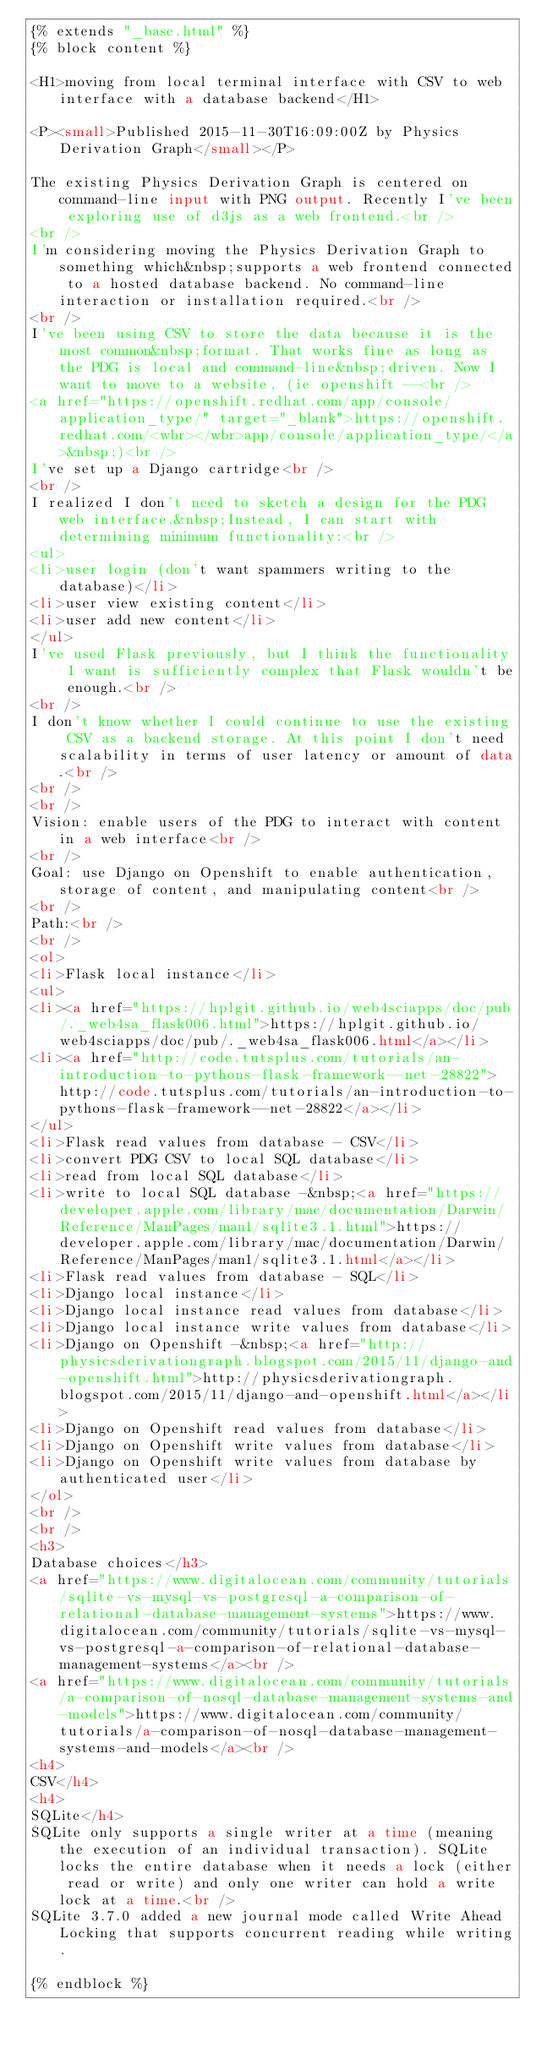<code> <loc_0><loc_0><loc_500><loc_500><_HTML_>{% extends "_base.html" %}
{% block content %}

<H1>moving from local terminal interface with CSV to web interface with a database backend</H1>

<P><small>Published 2015-11-30T16:09:00Z by Physics Derivation Graph</small></P>

The existing Physics Derivation Graph is centered on command-line input with PNG output. Recently I've been exploring use of d3js as a web frontend.<br />
<br />
I'm considering moving the Physics Derivation Graph to something which&nbsp;supports a web frontend connected to a hosted database backend. No command-line interaction or installation required.<br />
<br />
I've been using CSV to store the data because it is the most common&nbsp;format. That works fine as long as the PDG is local and command-line&nbsp;driven. Now I want to move to a website, (ie openshift --<br />
<a href="https://openshift.redhat.com/app/console/application_type/" target="_blank">https://openshift.redhat.com/<wbr></wbr>app/console/application_type/</a>&nbsp;)<br />
I've set up a Django cartridge<br />
<br />
I realized I don't need to sketch a design for the PDG web interface.&nbsp;Instead, I can start with determining minimum functionality:<br />
<ul>
<li>user login (don't want spammers writing to the database)</li>
<li>user view existing content</li>
<li>user add new content</li>
</ul>
I've used Flask previously, but I think the functionality I want is sufficiently complex that Flask wouldn't be enough.<br />
<br />
I don't know whether I could continue to use the existing CSV as a backend storage. At this point I don't need scalability in terms of user latency or amount of data.<br />
<br />
<br />
Vision: enable users of the PDG to interact with content in a web interface<br />
<br />
Goal: use Django on Openshift to enable authentication, storage of content, and manipulating content<br />
<br />
Path:<br />
<br />
<ol>
<li>Flask local instance</li>
<ul>
<li><a href="https://hplgit.github.io/web4sciapps/doc/pub/._web4sa_flask006.html">https://hplgit.github.io/web4sciapps/doc/pub/._web4sa_flask006.html</a></li>
<li><a href="http://code.tutsplus.com/tutorials/an-introduction-to-pythons-flask-framework--net-28822">http://code.tutsplus.com/tutorials/an-introduction-to-pythons-flask-framework--net-28822</a></li>
</ul>
<li>Flask read values from database - CSV</li>
<li>convert PDG CSV to local SQL database</li>
<li>read from local SQL database</li>
<li>write to local SQL database -&nbsp;<a href="https://developer.apple.com/library/mac/documentation/Darwin/Reference/ManPages/man1/sqlite3.1.html">https://developer.apple.com/library/mac/documentation/Darwin/Reference/ManPages/man1/sqlite3.1.html</a></li>
<li>Flask read values from database - SQL</li>
<li>Django local instance</li>
<li>Django local instance read values from database</li>
<li>Django local instance write values from database</li>
<li>Django on Openshift -&nbsp;<a href="http://physicsderivationgraph.blogspot.com/2015/11/django-and-openshift.html">http://physicsderivationgraph.blogspot.com/2015/11/django-and-openshift.html</a></li>
<li>Django on Openshift read values from database</li>
<li>Django on Openshift write values from database</li>
<li>Django on Openshift write values from database by authenticated user</li>
</ol>
<br />
<br />
<h3>
Database choices</h3>
<a href="https://www.digitalocean.com/community/tutorials/sqlite-vs-mysql-vs-postgresql-a-comparison-of-relational-database-management-systems">https://www.digitalocean.com/community/tutorials/sqlite-vs-mysql-vs-postgresql-a-comparison-of-relational-database-management-systems</a><br />
<a href="https://www.digitalocean.com/community/tutorials/a-comparison-of-nosql-database-management-systems-and-models">https://www.digitalocean.com/community/tutorials/a-comparison-of-nosql-database-management-systems-and-models</a><br />
<h4>
CSV</h4>
<h4>
SQLite</h4>
SQLite only supports a single writer at a time (meaning the execution of an individual transaction). SQLite locks the entire database when it needs a lock (either read or write) and only one writer can hold a write lock at a time.<br />
SQLite 3.7.0 added a new journal mode called Write Ahead Locking that supports concurrent reading while writing.

{% endblock %}</code> 